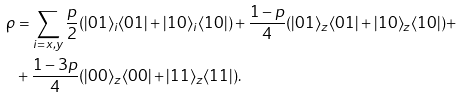Convert formula to latex. <formula><loc_0><loc_0><loc_500><loc_500>\rho & = \sum _ { i = x , y } \frac { p } { 2 } ( | 0 1 \rangle _ { i } \langle 0 1 | + | 1 0 \rangle _ { i } \langle 1 0 | ) + \frac { 1 - p } { 4 } ( | 0 1 \rangle _ { z } \langle 0 1 | + | 1 0 \rangle _ { z } \langle 1 0 | ) + \\ & + \frac { 1 - 3 p } { 4 } ( | 0 0 \rangle _ { z } \langle 0 0 | + | 1 1 \rangle _ { z } \langle 1 1 | ) .</formula> 